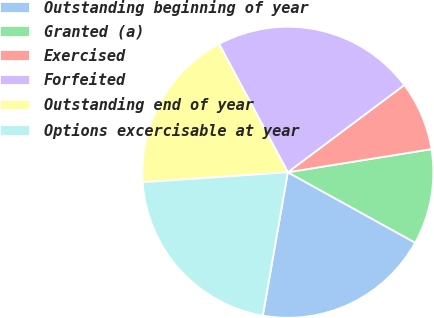Convert chart. <chart><loc_0><loc_0><loc_500><loc_500><pie_chart><fcel>Outstanding beginning of year<fcel>Granted (a)<fcel>Exercised<fcel>Forfeited<fcel>Outstanding end of year<fcel>Options excercisable at year<nl><fcel>19.71%<fcel>10.58%<fcel>7.69%<fcel>22.6%<fcel>18.27%<fcel>21.15%<nl></chart> 